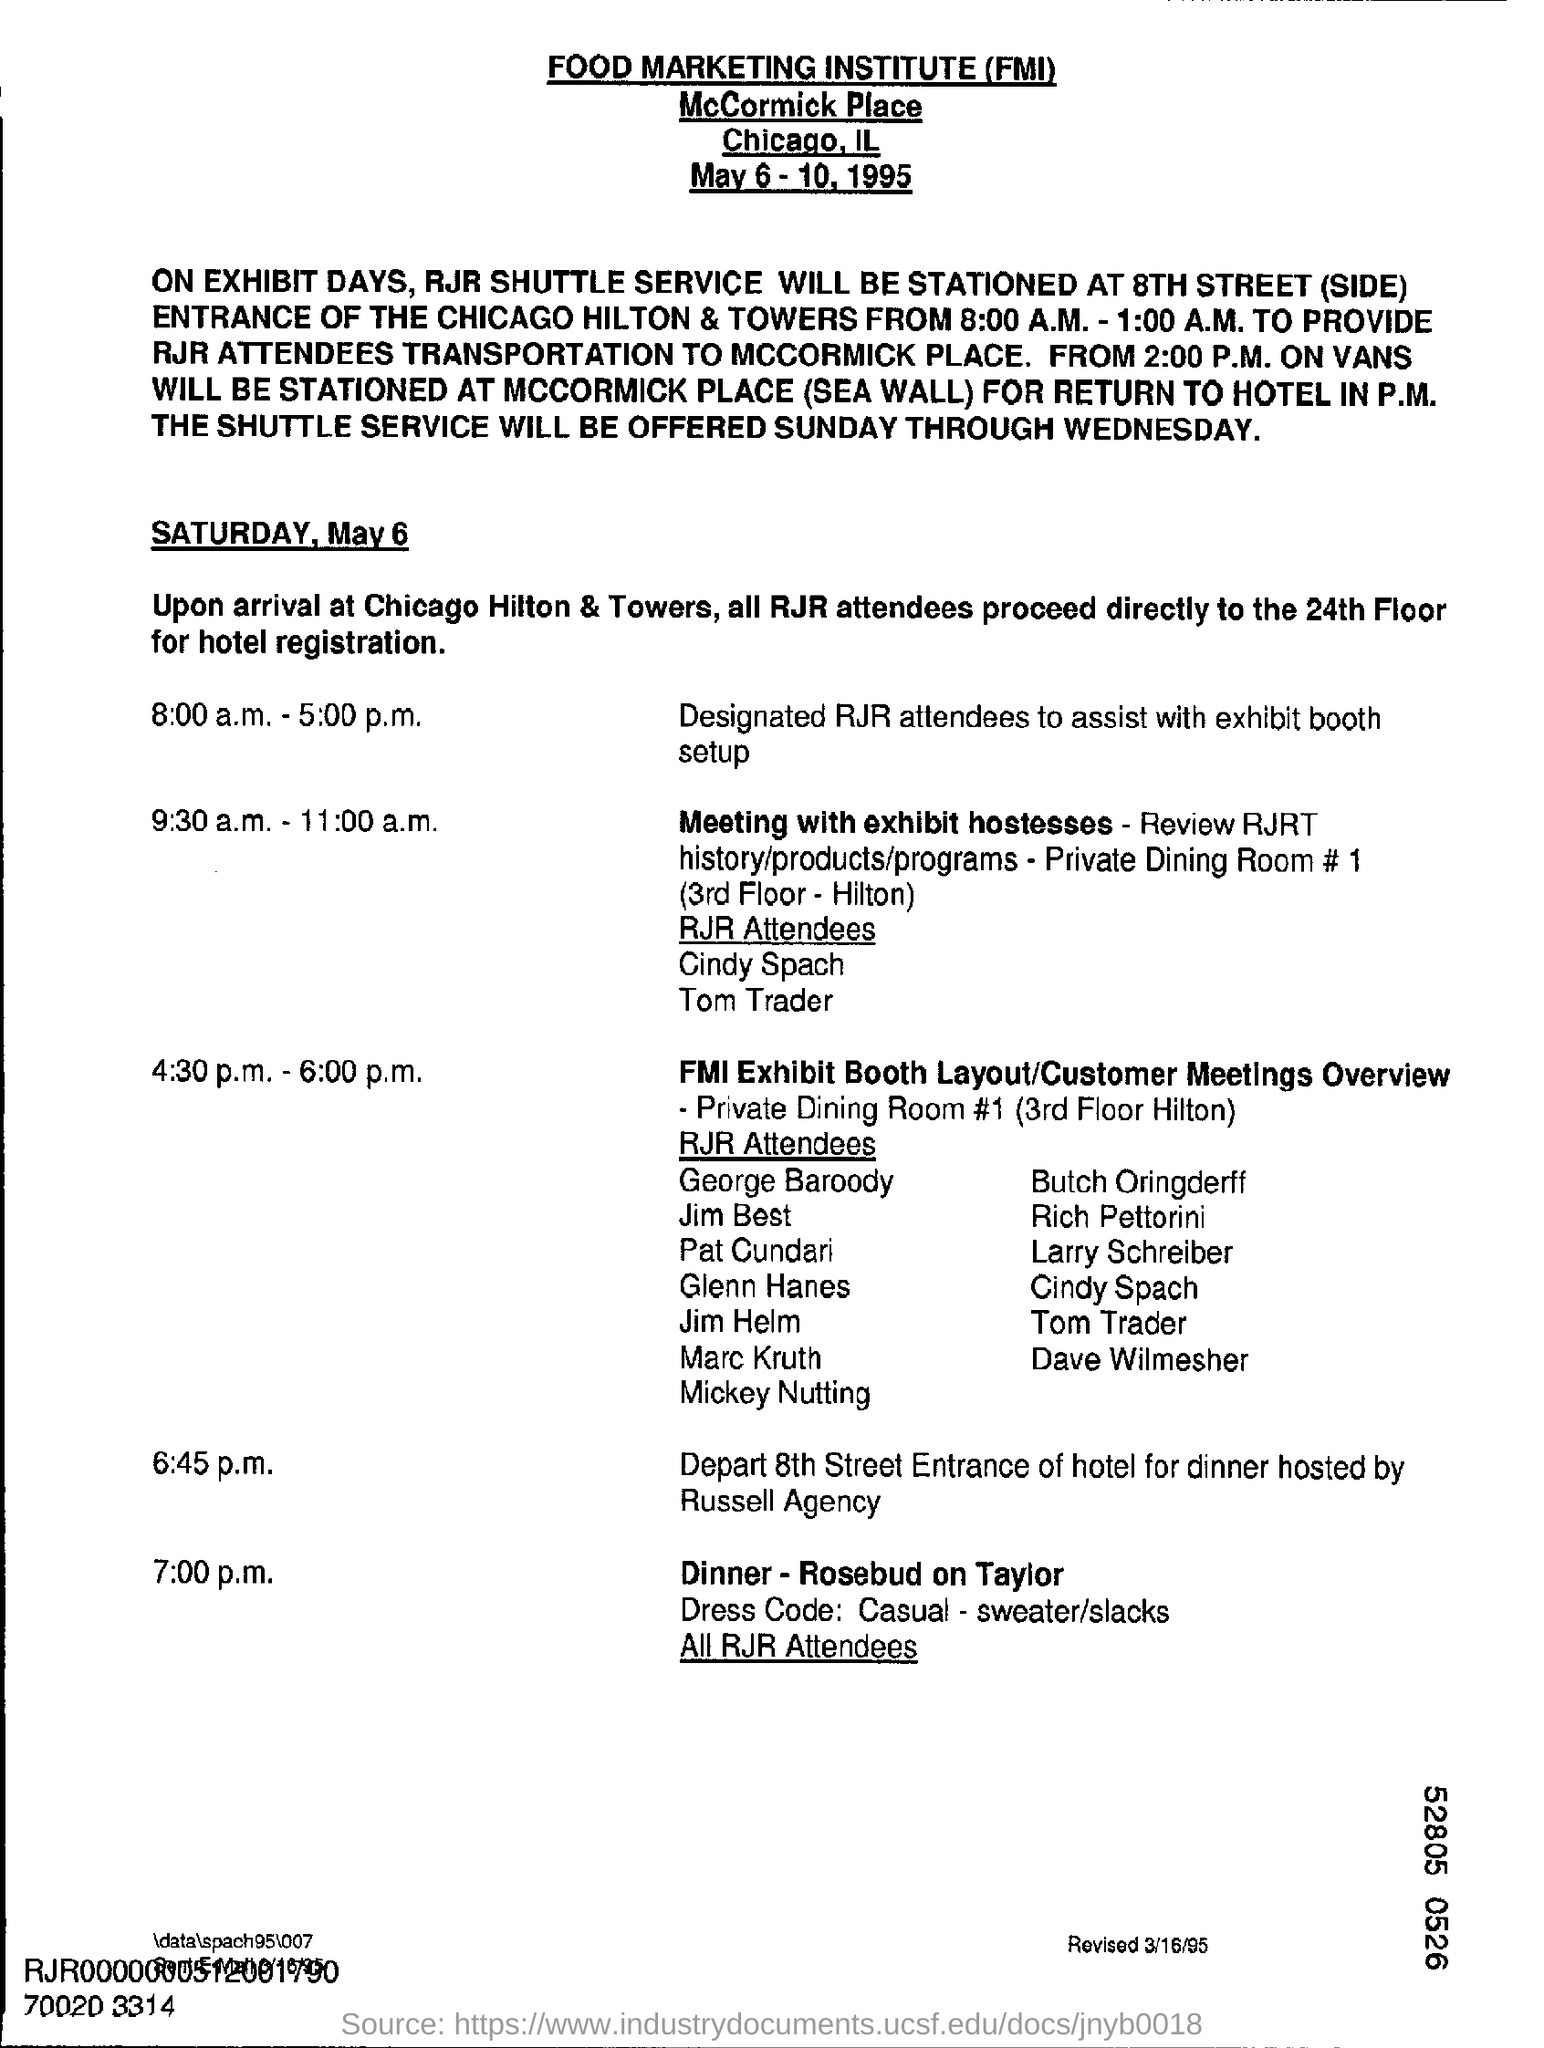What is the full form of FMI?
Make the answer very short. Food marketing institute. Where should all RJR attendees proceed to directly for hotel registration?
Provide a short and direct response. To the 24th floor. What program is scheduled from 4:30 p.m. -6:00 p.m. on May 6, Saturday?
Provide a short and direct response. FMI exhibit booth layout/customer meetings overview. What is the dress code for dinner at 7:00 p.m ?
Make the answer very short. Casual - sweater/slacks. When was the document revised?
Ensure brevity in your answer.  3/16/95. 